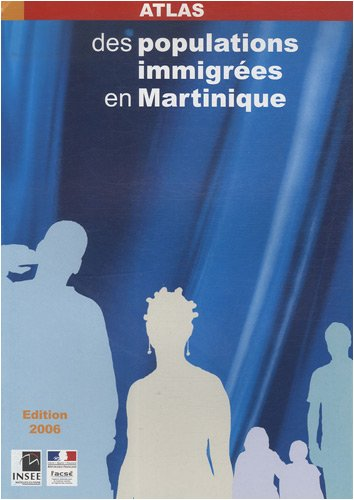What is the genre of this book? While initially classified as 'Travel', a more precise genre would be 'Socio-Demographic Study' or 'Statistical Atlas', given its focus on immigrant populations and their distribution across Martinique. 